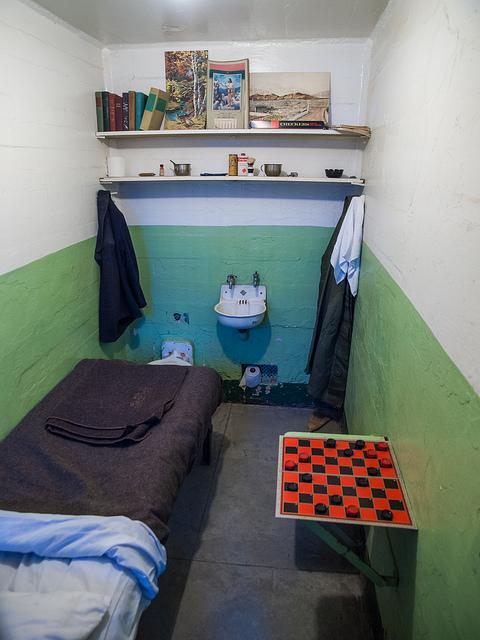Who most likely sleeps here?

Choices:
A) prisoner
B) grandmother
C) baby
D) landscaper prisoner 